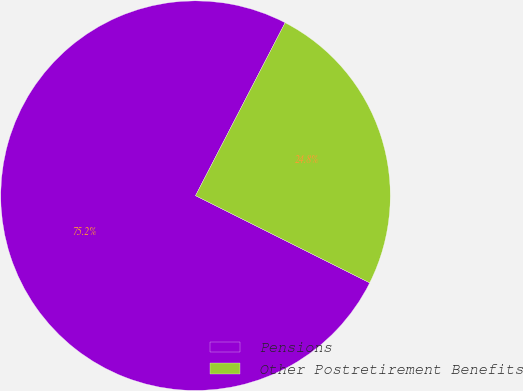Convert chart. <chart><loc_0><loc_0><loc_500><loc_500><pie_chart><fcel>Pensions<fcel>Other Postretirement Benefits<nl><fcel>75.22%<fcel>24.78%<nl></chart> 